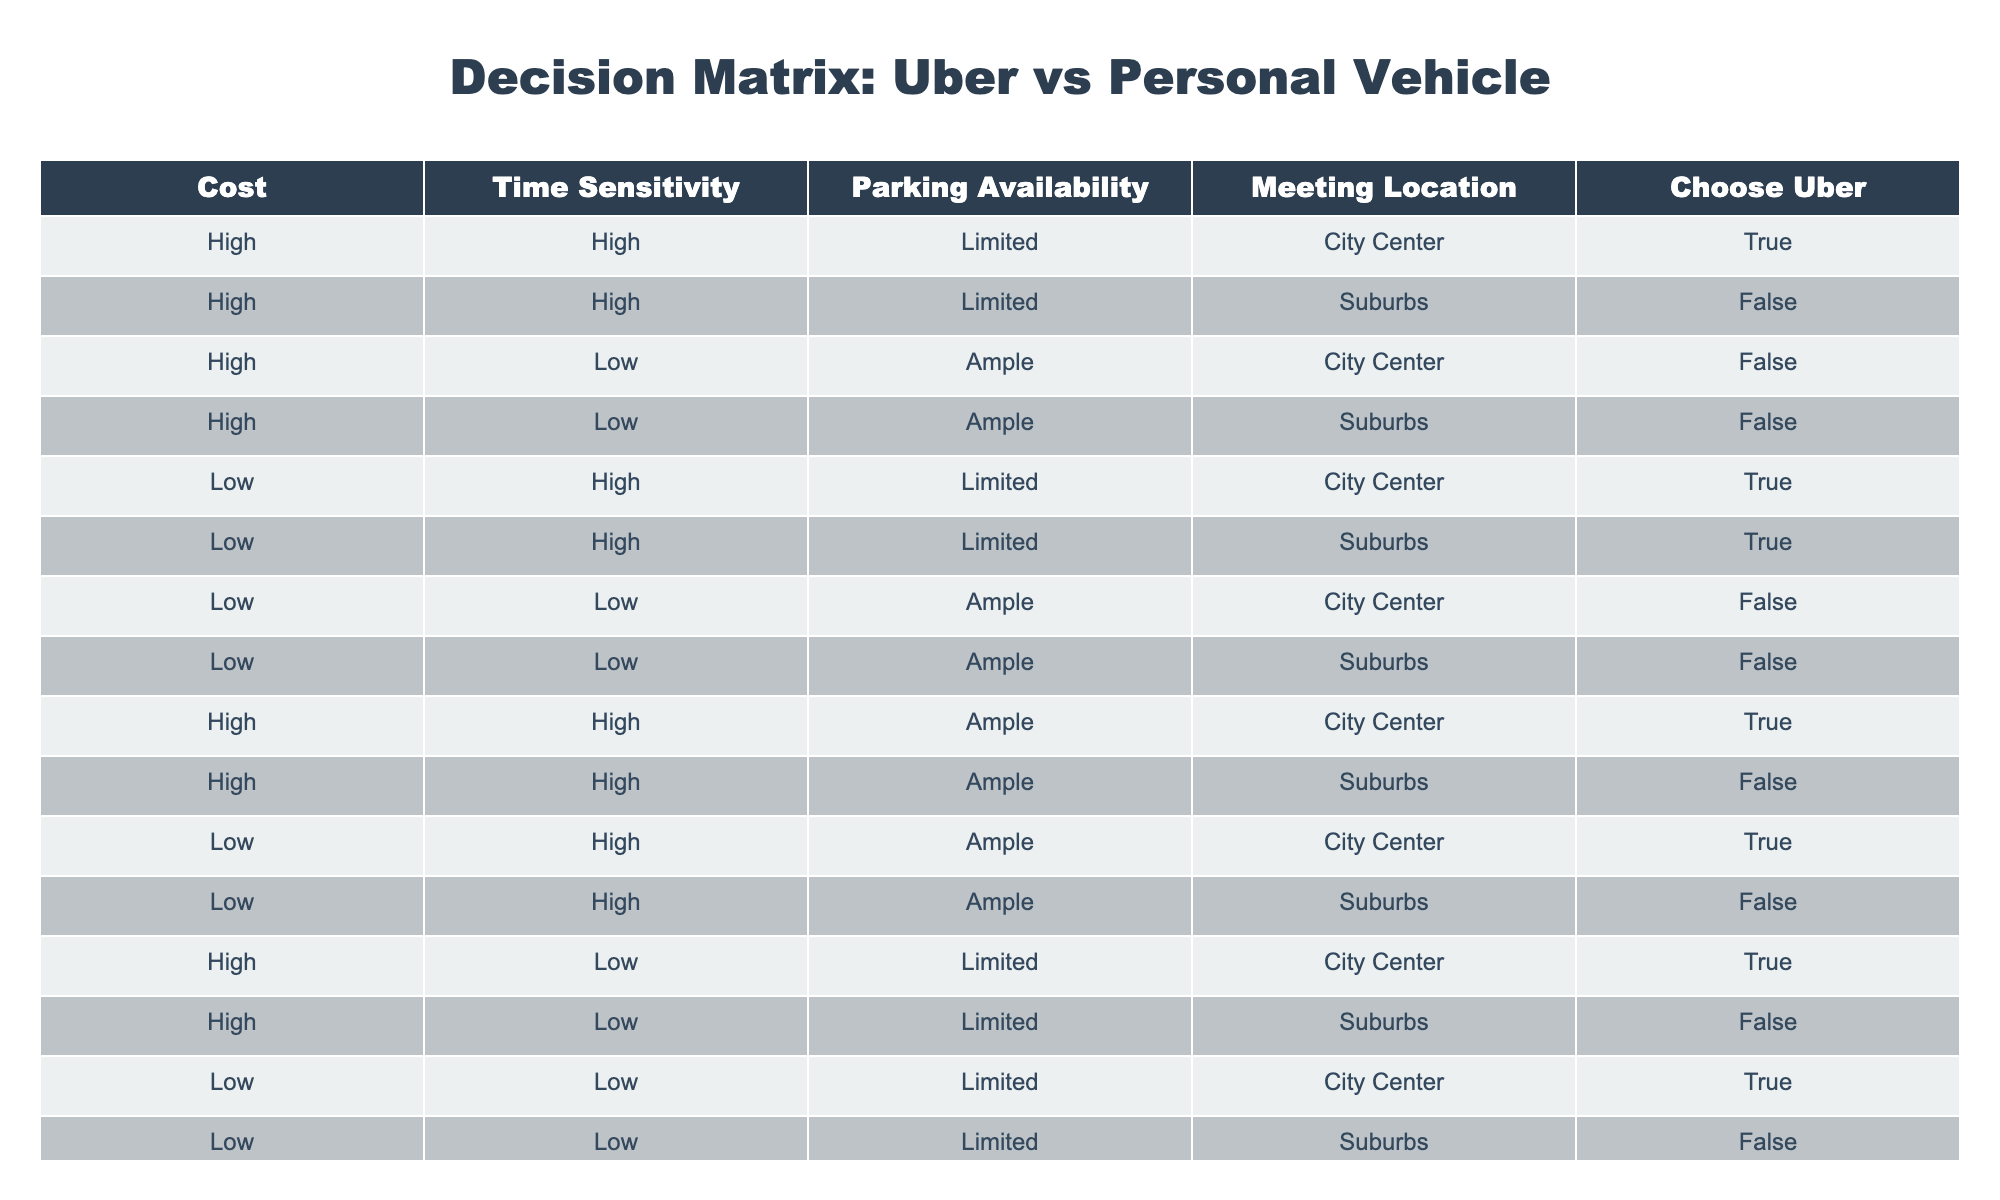What percentage of high-cost entries choose Uber? There are 6 high-cost entries in total. Out of these, 4 entries choose Uber. To find the percentage, I calculate (4/6) * 100, which gives me approximately 66.67%.
Answer: 66.67% In how many cases is Uber chosen when parking availability is limited? I check the rows where parking availability is limited, which gives me 6 rows. Out of these, Uber is chosen in 4 cases.
Answer: 4 What is the total number of instances where a personal vehicle is chosen in the suburbs? Looking at the suburbs with a personal vehicle, I find there are 4 instances where Uber is not chosen. This is the total count of personal vehicle choices in the suburbs.
Answer: 4 Is Uber chosen more often when the meeting location is in the city center or in the suburbs? I compare the Uber choices between city center and suburbs. In the city center, Uber is chosen 5 times whereas in the suburbs, it is chosen 2 times. Therefore, Uber is more often chosen in the city center.
Answer: City center What is the average time sensitivity for all cases where Uber is chosen? I filter for rows where Uber is chosen (8 entries) and check their time sensitivity. 6 of these entries are high time sensitivity and 2 are low. To find the average, I assign 1 for high and 0 for low: (6*1 + 2*0)/8 = 0.75, which indicates a tendency toward high time sensitivity.
Answer: 0.75 How many total entries have low cost and ample parking where Uber is not chosen? I look at the entries with low cost and ample parking. There are 4 such entries total, and out of these, Uber is not chosen in all 4 instances.
Answer: 4 Is it true that whenever parking is ample, Uber is not chosen? I analyze the rows where parking is ample, which occurs in 6 instances. Out of these, Uber is chosen in 3 cases, demonstrating that it's not true that Uber is never chosen when parking is ample.
Answer: No How many total cases are there where the time sensitivity is high and cost is low? I filter the rows for high time sensitivity and low cost. There are 3 cases fitting this criterion, so the total number is 3.
Answer: 3 